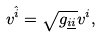<formula> <loc_0><loc_0><loc_500><loc_500>v ^ { \hat { i } } = \sqrt { g _ { \underline { i } \underline { i } } } v ^ { i } ,</formula> 